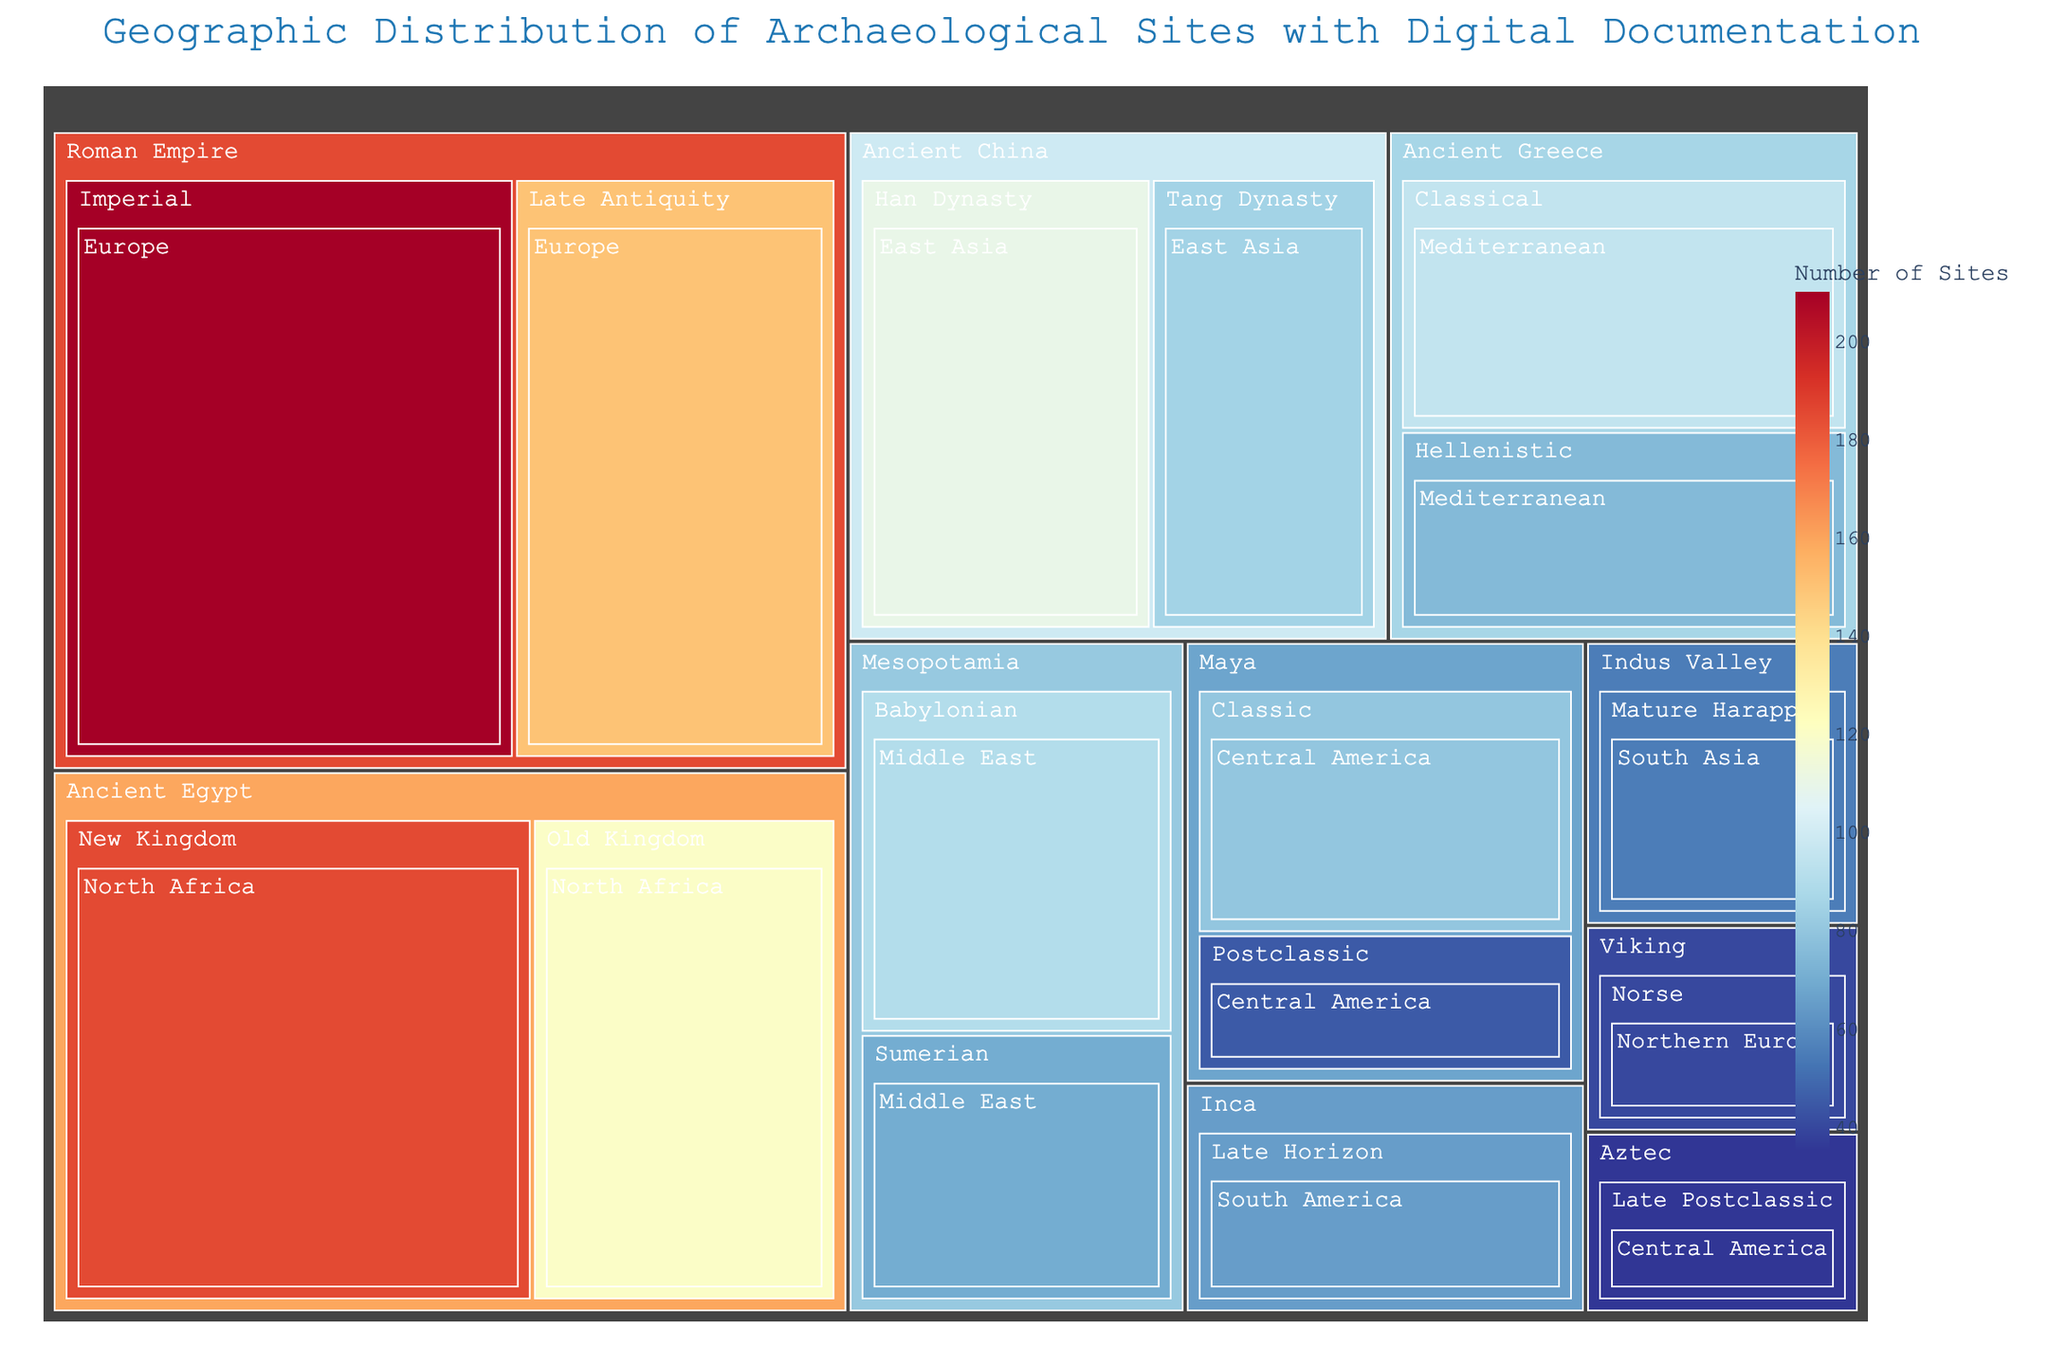How many archaeological sites are documented for the Old Kingdom era in Ancient Egypt? Look at the block labeled Ancient Egypt and find Old Kingdom. The figure shows 120 sites for Old Kingdom in Ancient Egypt.
Answer: 120 Which civilization has the highest number of documented archaeological sites? Observe the size of the blocks in each civilization. The Roman Empire has the largest block, indicating it has the highest number of sites.
Answer: Roman Empire What is the combined number of sites for both the Classical and Hellenistic eras of Ancient Greece? Add the number of sites from the Classical era (95) and the Hellenistic era (75) in Ancient Greece. So, 95 + 75 = 170.
Answer: 170 Which region in Central America has the most documented sites, and which civilizations do they belong to? Examine the blocks within Central America to see the number of sites and their corresponding civilizations. The Classic Maya has 80 sites, which is more than the 45 sites of the Postclassic Maya and 35 sites of the Aztec. Therefore, the region with the most sites is Central America, specifically belonging to the Classic Maya civilization.
Answer: Classic Maya Which era of the Roman Empire has more documented sites, Imperial or Late Antiquity? Compare the blocks for Imperial and Late Antiquity under the Roman Empire. The Imperial era has 210 sites, while Late Antiquity has 150 sites.
Answer: Imperial What is the total number of archaeological sites documented in East Asia? Sum the number of sites in East Asia: Han Dynasty (110) + Tang Dynasty (85). Therefore, 110 + 85 = 195.
Answer: 195 Which South American civilization has documented archaeological sites, and how many are there? Locate the South American region and observe the blocks within it. The Inca civilization has 65 documented sites.
Answer: Inca, 65 How does the number of sites from the Han Dynasty compare to those of the Tang Dynasty in Ancient China? Compare the size of the blocks for the Han Dynasty (110 sites) and the Tang Dynasty (85 sites). The Han Dynasty has more documented sites.
Answer: Han Dynasty has more What are the total sites documented for the Middle East regions combined? Add the sites for the Sumerian era (70) and Babylonian era (90) in Mesopotamia. So, 70 + 90 = 160.
Answer: 160 Between the Maya Classic and Maya Postclassic eras, which one has fewer documented sites? Compare the number of sites: Maya Classic (80) and Maya Postclassic (45). The Maya Postclassic has fewer sites.
Answer: Maya Postclassic 